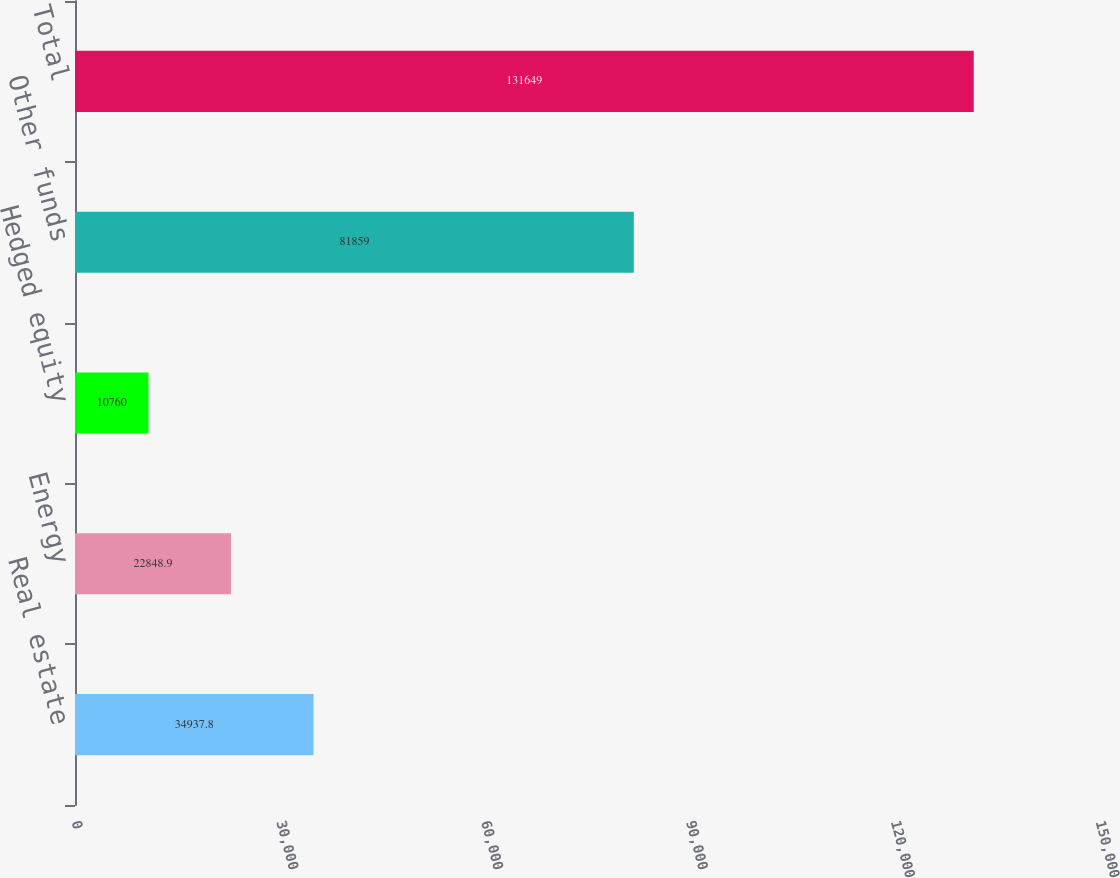Convert chart to OTSL. <chart><loc_0><loc_0><loc_500><loc_500><bar_chart><fcel>Real estate<fcel>Energy<fcel>Hedged equity<fcel>Other funds<fcel>Total<nl><fcel>34937.8<fcel>22848.9<fcel>10760<fcel>81859<fcel>131649<nl></chart> 